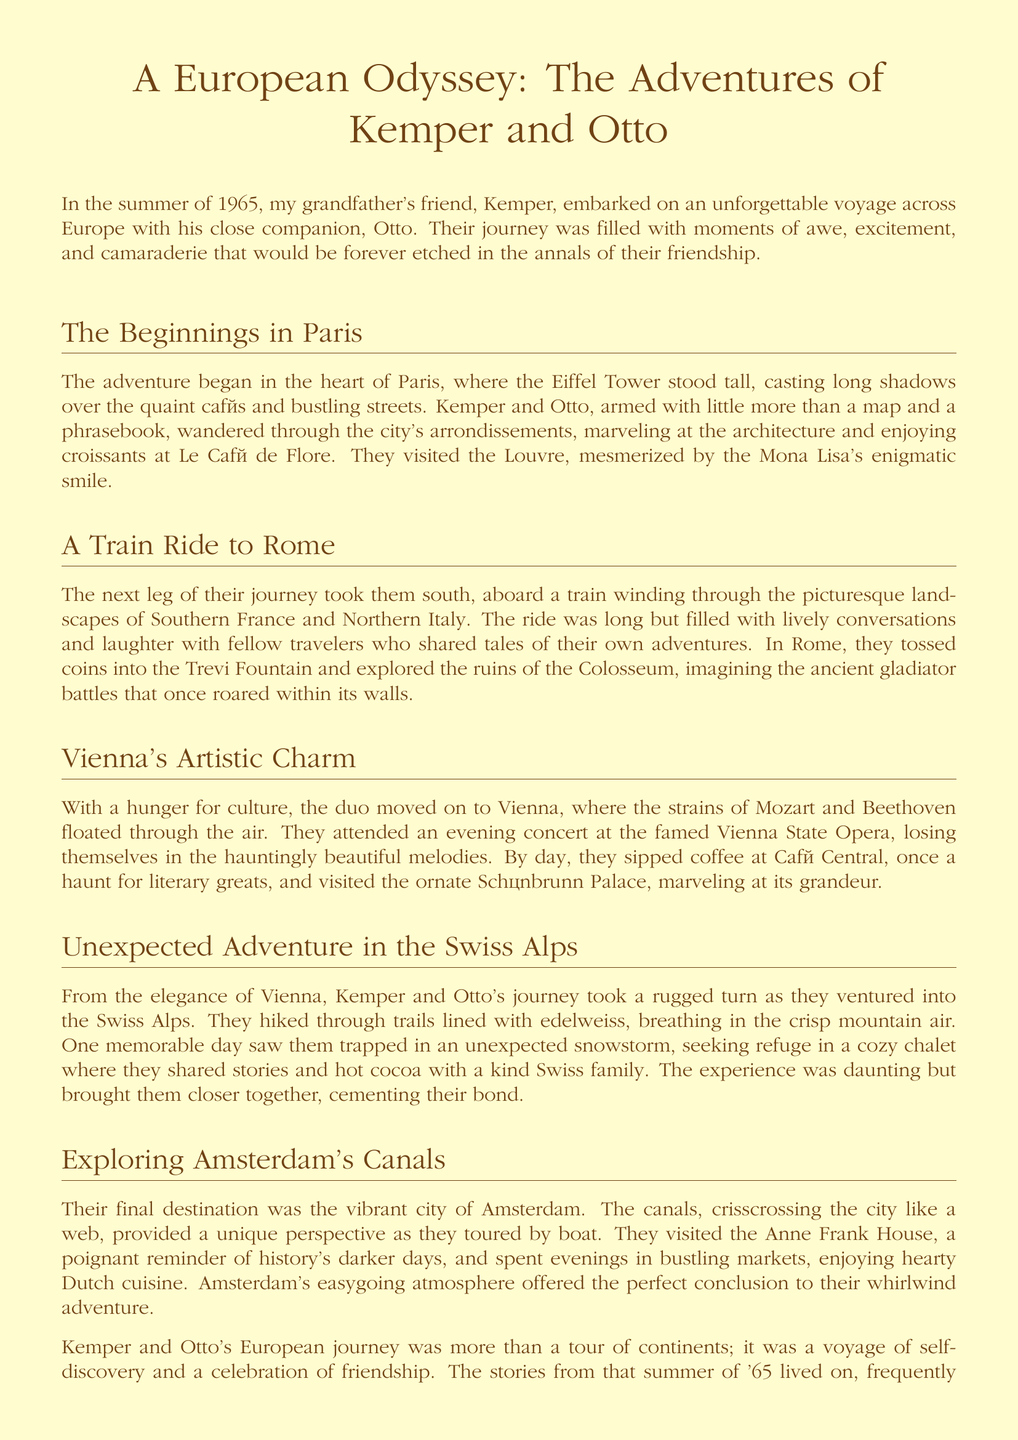What year did Kemper and Otto start their journey? The memoir recounts the beginning of Kemper and Otto's journey as occurring in the summer of 1965.
Answer: 1965 Where did Kemper and Otto have croissants? The document mentions that they enjoyed croissants at Le Café de Flore in Paris.
Answer: Le Café de Flore What was the name of the opera they attended in Vienna? The evening concert they attended was at the famed Vienna State Opera.
Answer: Vienna State Opera What weather event did they experience in the Swiss Alps? They faced an unexpected snowstorm during their hike in the Swiss Alps.
Answer: snowstorm What famous historical site did they visit in Amsterdam? They visited the Anne Frank House in Amsterdam, which is a poignant reminder of history.
Answer: Anne Frank House Which city did they visit after Rome? The document states that after Rome, they moved on to Vienna.
Answer: Vienna How did Kemper and Otto travel to their next destination after Paris? They took a train for the next leg of their journey, heading south to Rome.
Answer: train What was a memorable experience they shared in a Swiss chalet? They shared stories and hot cocoa with a kind Swiss family while seeking refuge from the storm.
Answer: hot cocoa What overall theme does the memoir convey about their journey? The story reflects themes of self-discovery and the celebration of friendship throughout their adventure.
Answer: friendship 